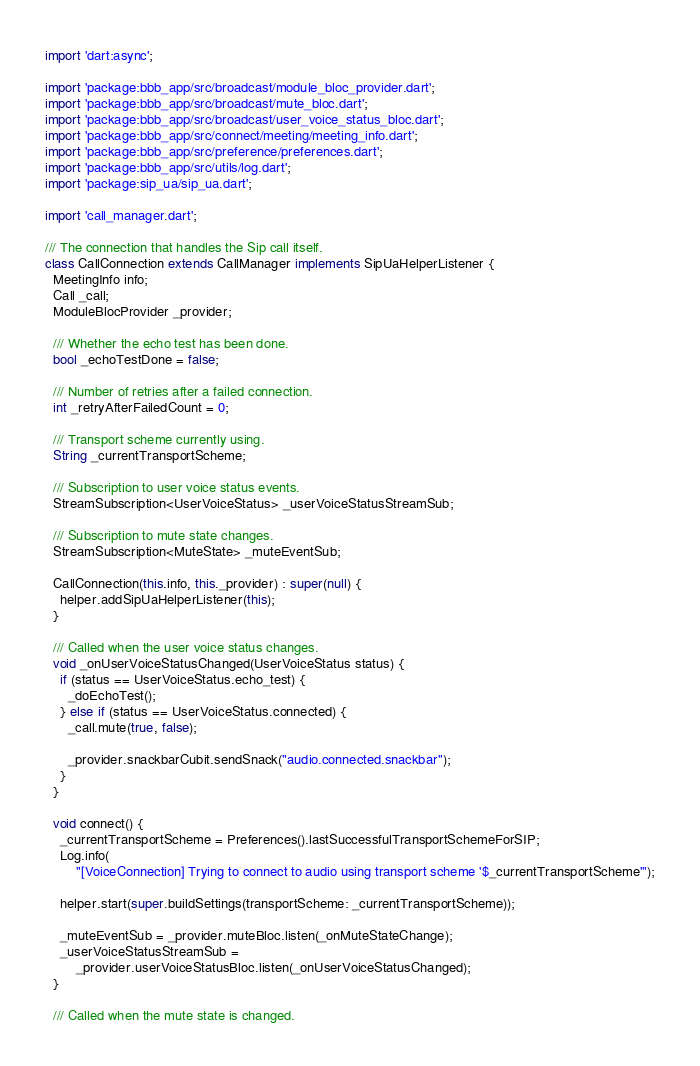<code> <loc_0><loc_0><loc_500><loc_500><_Dart_>import 'dart:async';

import 'package:bbb_app/src/broadcast/module_bloc_provider.dart';
import 'package:bbb_app/src/broadcast/mute_bloc.dart';
import 'package:bbb_app/src/broadcast/user_voice_status_bloc.dart';
import 'package:bbb_app/src/connect/meeting/meeting_info.dart';
import 'package:bbb_app/src/preference/preferences.dart';
import 'package:bbb_app/src/utils/log.dart';
import 'package:sip_ua/sip_ua.dart';

import 'call_manager.dart';

/// The connection that handles the Sip call itself.
class CallConnection extends CallManager implements SipUaHelperListener {
  MeetingInfo info;
  Call _call;
  ModuleBlocProvider _provider;

  /// Whether the echo test has been done.
  bool _echoTestDone = false;

  /// Number of retries after a failed connection.
  int _retryAfterFailedCount = 0;

  /// Transport scheme currently using.
  String _currentTransportScheme;

  /// Subscription to user voice status events.
  StreamSubscription<UserVoiceStatus> _userVoiceStatusStreamSub;

  /// Subscription to mute state changes.
  StreamSubscription<MuteState> _muteEventSub;

  CallConnection(this.info, this._provider) : super(null) {
    helper.addSipUaHelperListener(this);
  }

  /// Called when the user voice status changes.
  void _onUserVoiceStatusChanged(UserVoiceStatus status) {
    if (status == UserVoiceStatus.echo_test) {
      _doEchoTest();
    } else if (status == UserVoiceStatus.connected) {
      _call.mute(true, false);

      _provider.snackbarCubit.sendSnack("audio.connected.snackbar");
    }
  }

  void connect() {
    _currentTransportScheme = Preferences().lastSuccessfulTransportSchemeForSIP;
    Log.info(
        "[VoiceConnection] Trying to connect to audio using transport scheme '$_currentTransportScheme'");

    helper.start(super.buildSettings(transportScheme: _currentTransportScheme));

    _muteEventSub = _provider.muteBloc.listen(_onMuteStateChange);
    _userVoiceStatusStreamSub =
        _provider.userVoiceStatusBloc.listen(_onUserVoiceStatusChanged);
  }

  /// Called when the mute state is changed.</code> 